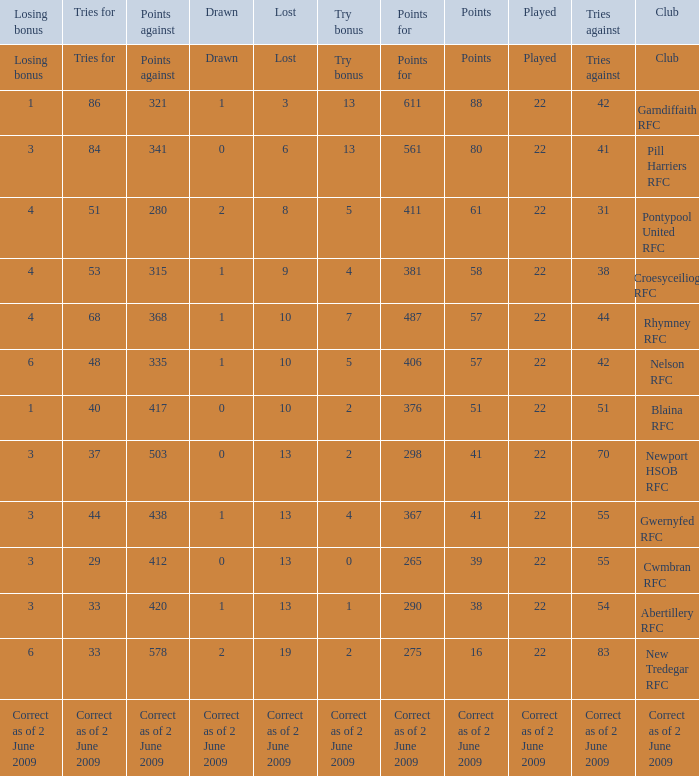How many tries against did the club with 1 drawn and 41 points have? 55.0. 